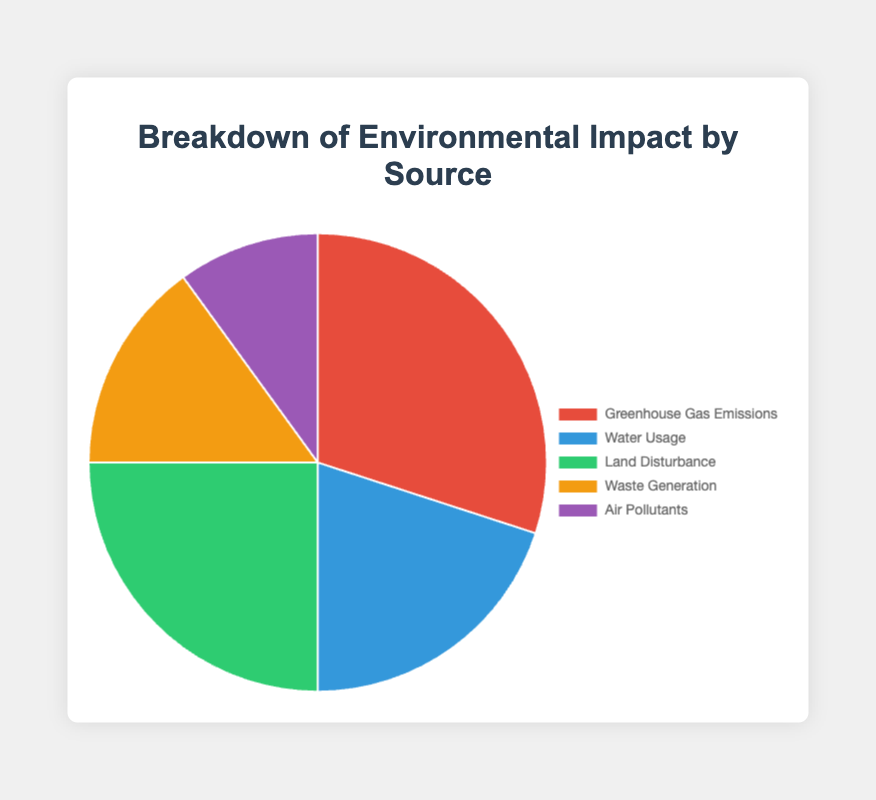What percentage of the environmental impact is due to Air Pollutants? Locate "Air Pollutants" in the pie chart and refer to the associated percentage label.
Answer: 10% Which source has the highest percentage of environmental impact? Identify the largest segment or label with the highest percentage in the pie chart.
Answer: Greenhouse Gas Emissions What is the combined percentage of Water Usage and Land Disturbance? Find the segments for "Water Usage" and "Land Disturbance", then add their percentages: 20% + 25%
Answer: 45% Which sources combined contribute to half (50%) of the environmental impact? Look for sources whose percentages add up to approximately 50%. "Greenhouse Gas Emissions" (30%) + "Water Usage" (20%) = 50%.
Answer: Greenhouse Gas Emissions and Water Usage Is the environmental impact from Waste Generation greater than that from Air Pollutants? Compare the percentages of "Waste Generation" and "Air Pollutants". Waste Generation is 15% and Air Pollutants is 10%.
Answer: Yes How much more significant is Greenhouse Gas Emissions compared to Air Pollutants? Subtract the percentage of "Air Pollutants" from "Greenhouse Gas Emissions": 30% - 10%
Answer: 20% Which source has the second lowest impact percentage, and what is it? Identify the source with the second smallest segment next to the smallest one (Air Pollutants).
Answer: Waste Generation, 15% What is the average percentage of all sources of environmental impact? Sum the percentages of all sources and divide by the total number of sources: (30% + 20% + 25% + 15% + 10%) / 5 = 100% / 5
Answer: 20% Are Water Usage and Land Disturbance together greater than Greenhouse Gas Emissions? Add the percentages of "Water Usage" and "Land Disturbance": 20% + 25% = 45%, and compare with "Greenhouse Gas Emissions" which is 30%.
Answer: Yes If Greenhouse Gas Emissions were to reduce by 5 percentage points, what would its new value be? Subtract 5 from the current percentage of "Greenhouse Gas Emissions": 30% - 5%
Answer: 25% 